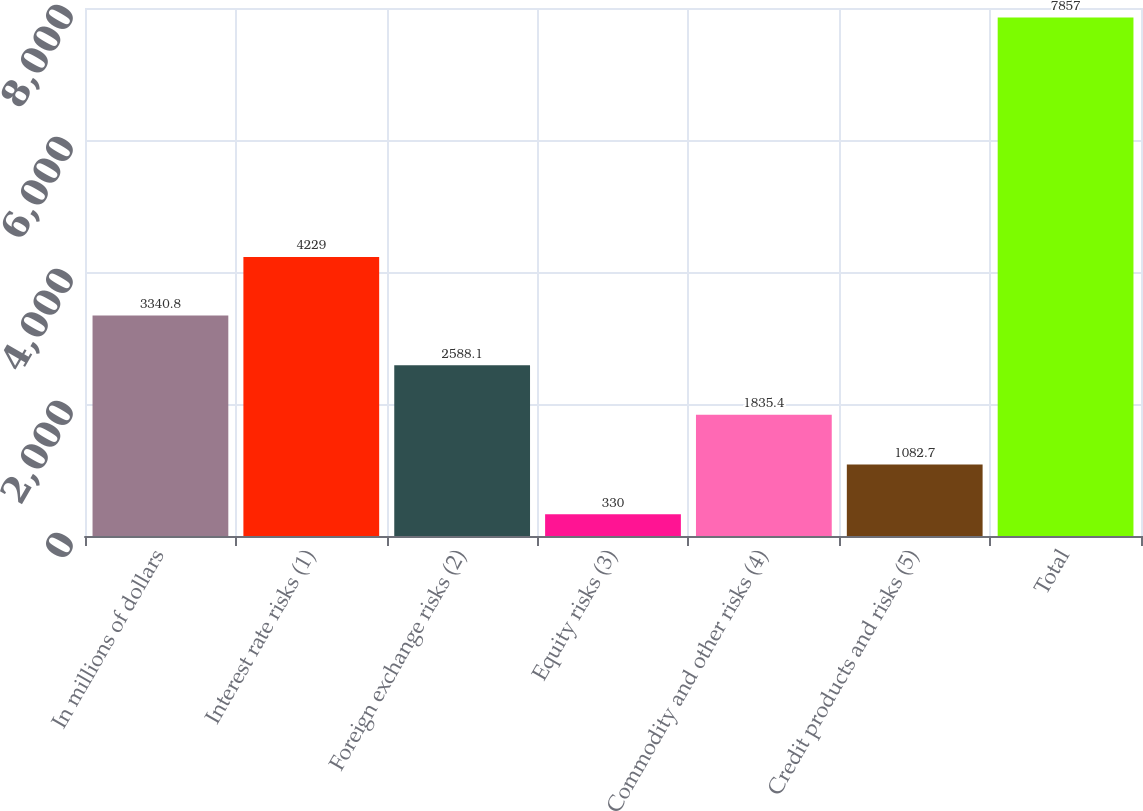<chart> <loc_0><loc_0><loc_500><loc_500><bar_chart><fcel>In millions of dollars<fcel>Interest rate risks (1)<fcel>Foreign exchange risks (2)<fcel>Equity risks (3)<fcel>Commodity and other risks (4)<fcel>Credit products and risks (5)<fcel>Total<nl><fcel>3340.8<fcel>4229<fcel>2588.1<fcel>330<fcel>1835.4<fcel>1082.7<fcel>7857<nl></chart> 